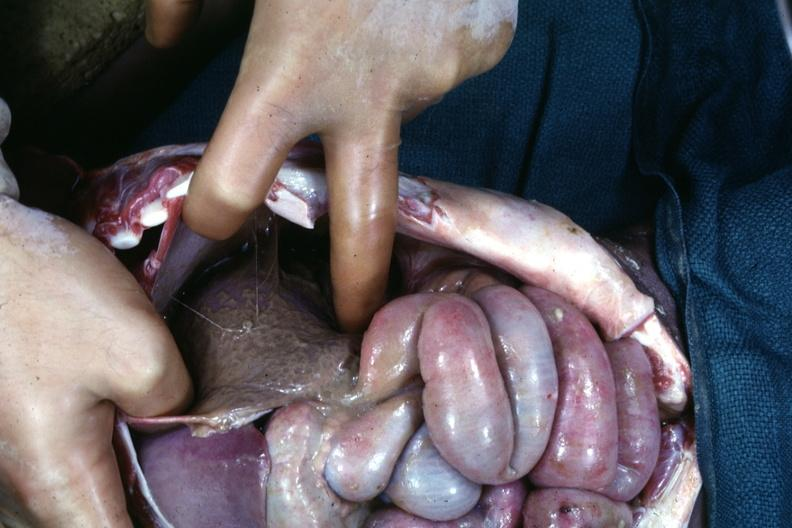what is present?
Answer the question using a single word or phrase. Abdomen 